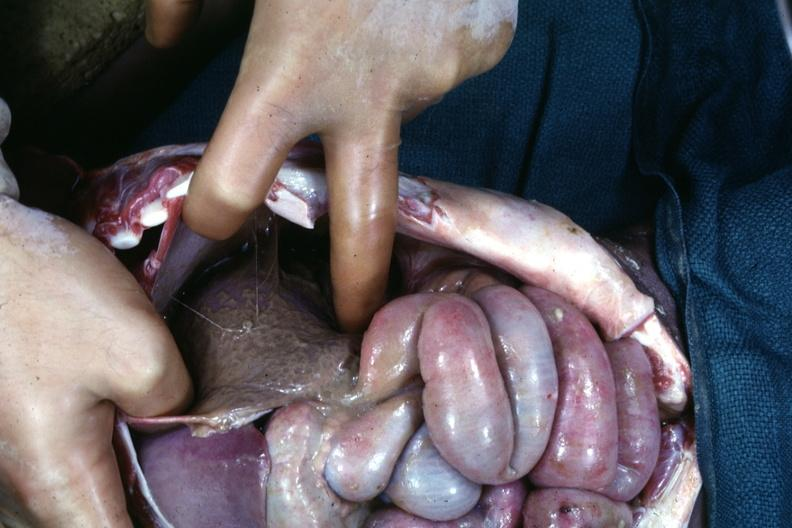what is present?
Answer the question using a single word or phrase. Abdomen 